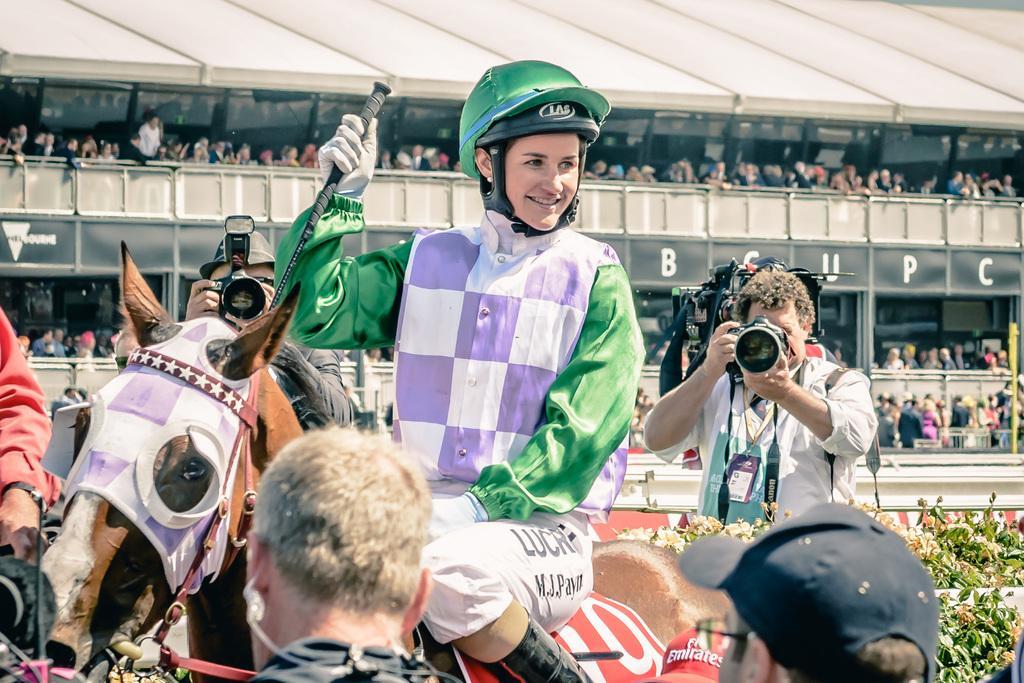Could you give a brief overview of what you see in this image? In this image we can see many people, there are cameras, plants, we can see the horse, in the background there is a fence and written text. 